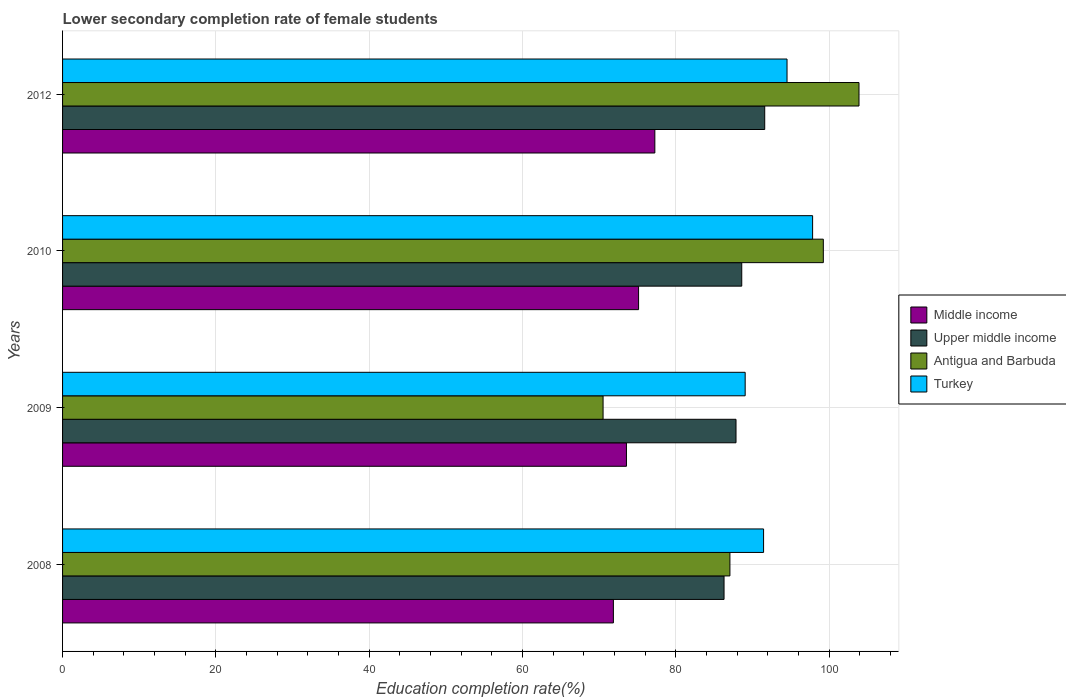How many groups of bars are there?
Provide a short and direct response. 4. Are the number of bars per tick equal to the number of legend labels?
Your answer should be compact. Yes. What is the label of the 1st group of bars from the top?
Offer a very short reply. 2012. What is the lower secondary completion rate of female students in Antigua and Barbuda in 2008?
Give a very brief answer. 87.07. Across all years, what is the maximum lower secondary completion rate of female students in Upper middle income?
Offer a terse response. 91.61. Across all years, what is the minimum lower secondary completion rate of female students in Antigua and Barbuda?
Your response must be concise. 70.52. In which year was the lower secondary completion rate of female students in Antigua and Barbuda minimum?
Give a very brief answer. 2009. What is the total lower secondary completion rate of female students in Upper middle income in the graph?
Give a very brief answer. 354.4. What is the difference between the lower secondary completion rate of female students in Middle income in 2009 and that in 2012?
Your answer should be very brief. -3.7. What is the difference between the lower secondary completion rate of female students in Middle income in 2009 and the lower secondary completion rate of female students in Antigua and Barbuda in 2008?
Provide a succinct answer. -13.5. What is the average lower secondary completion rate of female students in Turkey per year?
Offer a terse response. 93.23. In the year 2012, what is the difference between the lower secondary completion rate of female students in Turkey and lower secondary completion rate of female students in Middle income?
Ensure brevity in your answer.  17.25. What is the ratio of the lower secondary completion rate of female students in Antigua and Barbuda in 2010 to that in 2012?
Offer a very short reply. 0.96. What is the difference between the highest and the second highest lower secondary completion rate of female students in Upper middle income?
Offer a terse response. 3. What is the difference between the highest and the lowest lower secondary completion rate of female students in Upper middle income?
Provide a succinct answer. 5.31. In how many years, is the lower secondary completion rate of female students in Turkey greater than the average lower secondary completion rate of female students in Turkey taken over all years?
Ensure brevity in your answer.  2. Is the sum of the lower secondary completion rate of female students in Antigua and Barbuda in 2009 and 2010 greater than the maximum lower secondary completion rate of female students in Middle income across all years?
Make the answer very short. Yes. Is it the case that in every year, the sum of the lower secondary completion rate of female students in Upper middle income and lower secondary completion rate of female students in Middle income is greater than the sum of lower secondary completion rate of female students in Turkey and lower secondary completion rate of female students in Antigua and Barbuda?
Make the answer very short. Yes. What does the 2nd bar from the top in 2012 represents?
Offer a very short reply. Antigua and Barbuda. What does the 4th bar from the bottom in 2009 represents?
Give a very brief answer. Turkey. How many bars are there?
Your response must be concise. 16. Are all the bars in the graph horizontal?
Offer a very short reply. Yes. How many years are there in the graph?
Keep it short and to the point. 4. What is the difference between two consecutive major ticks on the X-axis?
Your answer should be very brief. 20. Does the graph contain any zero values?
Your response must be concise. No. How are the legend labels stacked?
Offer a very short reply. Vertical. What is the title of the graph?
Give a very brief answer. Lower secondary completion rate of female students. Does "United States" appear as one of the legend labels in the graph?
Offer a terse response. No. What is the label or title of the X-axis?
Your answer should be very brief. Education completion rate(%). What is the Education completion rate(%) of Middle income in 2008?
Your response must be concise. 71.87. What is the Education completion rate(%) in Upper middle income in 2008?
Your answer should be very brief. 86.31. What is the Education completion rate(%) in Antigua and Barbuda in 2008?
Provide a short and direct response. 87.07. What is the Education completion rate(%) in Turkey in 2008?
Offer a terse response. 91.46. What is the Education completion rate(%) of Middle income in 2009?
Your response must be concise. 73.57. What is the Education completion rate(%) in Upper middle income in 2009?
Ensure brevity in your answer.  87.87. What is the Education completion rate(%) of Antigua and Barbuda in 2009?
Offer a terse response. 70.52. What is the Education completion rate(%) of Turkey in 2009?
Ensure brevity in your answer.  89.06. What is the Education completion rate(%) in Middle income in 2010?
Your answer should be compact. 75.15. What is the Education completion rate(%) in Upper middle income in 2010?
Your response must be concise. 88.62. What is the Education completion rate(%) in Antigua and Barbuda in 2010?
Provide a succinct answer. 99.26. What is the Education completion rate(%) of Turkey in 2010?
Your answer should be very brief. 97.86. What is the Education completion rate(%) of Middle income in 2012?
Give a very brief answer. 77.28. What is the Education completion rate(%) in Upper middle income in 2012?
Provide a succinct answer. 91.61. What is the Education completion rate(%) in Antigua and Barbuda in 2012?
Your answer should be compact. 103.91. What is the Education completion rate(%) of Turkey in 2012?
Offer a terse response. 94.52. Across all years, what is the maximum Education completion rate(%) in Middle income?
Your answer should be compact. 77.28. Across all years, what is the maximum Education completion rate(%) in Upper middle income?
Give a very brief answer. 91.61. Across all years, what is the maximum Education completion rate(%) in Antigua and Barbuda?
Make the answer very short. 103.91. Across all years, what is the maximum Education completion rate(%) of Turkey?
Offer a very short reply. 97.86. Across all years, what is the minimum Education completion rate(%) in Middle income?
Offer a very short reply. 71.87. Across all years, what is the minimum Education completion rate(%) in Upper middle income?
Make the answer very short. 86.31. Across all years, what is the minimum Education completion rate(%) in Antigua and Barbuda?
Offer a very short reply. 70.52. Across all years, what is the minimum Education completion rate(%) of Turkey?
Your response must be concise. 89.06. What is the total Education completion rate(%) in Middle income in the graph?
Make the answer very short. 297.87. What is the total Education completion rate(%) of Upper middle income in the graph?
Ensure brevity in your answer.  354.4. What is the total Education completion rate(%) in Antigua and Barbuda in the graph?
Provide a succinct answer. 360.77. What is the total Education completion rate(%) of Turkey in the graph?
Keep it short and to the point. 372.91. What is the difference between the Education completion rate(%) of Middle income in 2008 and that in 2009?
Your answer should be very brief. -1.7. What is the difference between the Education completion rate(%) of Upper middle income in 2008 and that in 2009?
Provide a short and direct response. -1.56. What is the difference between the Education completion rate(%) of Antigua and Barbuda in 2008 and that in 2009?
Provide a short and direct response. 16.55. What is the difference between the Education completion rate(%) of Turkey in 2008 and that in 2009?
Make the answer very short. 2.4. What is the difference between the Education completion rate(%) in Middle income in 2008 and that in 2010?
Your answer should be compact. -3.29. What is the difference between the Education completion rate(%) in Upper middle income in 2008 and that in 2010?
Offer a terse response. -2.31. What is the difference between the Education completion rate(%) of Antigua and Barbuda in 2008 and that in 2010?
Provide a succinct answer. -12.19. What is the difference between the Education completion rate(%) in Turkey in 2008 and that in 2010?
Your answer should be compact. -6.4. What is the difference between the Education completion rate(%) in Middle income in 2008 and that in 2012?
Keep it short and to the point. -5.41. What is the difference between the Education completion rate(%) in Upper middle income in 2008 and that in 2012?
Your response must be concise. -5.31. What is the difference between the Education completion rate(%) of Antigua and Barbuda in 2008 and that in 2012?
Provide a succinct answer. -16.84. What is the difference between the Education completion rate(%) of Turkey in 2008 and that in 2012?
Keep it short and to the point. -3.06. What is the difference between the Education completion rate(%) in Middle income in 2009 and that in 2010?
Ensure brevity in your answer.  -1.58. What is the difference between the Education completion rate(%) in Upper middle income in 2009 and that in 2010?
Your answer should be compact. -0.75. What is the difference between the Education completion rate(%) in Antigua and Barbuda in 2009 and that in 2010?
Keep it short and to the point. -28.74. What is the difference between the Education completion rate(%) in Turkey in 2009 and that in 2010?
Offer a terse response. -8.8. What is the difference between the Education completion rate(%) in Middle income in 2009 and that in 2012?
Provide a short and direct response. -3.7. What is the difference between the Education completion rate(%) in Upper middle income in 2009 and that in 2012?
Make the answer very short. -3.75. What is the difference between the Education completion rate(%) in Antigua and Barbuda in 2009 and that in 2012?
Your answer should be very brief. -33.39. What is the difference between the Education completion rate(%) of Turkey in 2009 and that in 2012?
Your answer should be very brief. -5.46. What is the difference between the Education completion rate(%) in Middle income in 2010 and that in 2012?
Provide a succinct answer. -2.12. What is the difference between the Education completion rate(%) in Upper middle income in 2010 and that in 2012?
Keep it short and to the point. -3. What is the difference between the Education completion rate(%) of Antigua and Barbuda in 2010 and that in 2012?
Your answer should be very brief. -4.65. What is the difference between the Education completion rate(%) in Turkey in 2010 and that in 2012?
Keep it short and to the point. 3.34. What is the difference between the Education completion rate(%) of Middle income in 2008 and the Education completion rate(%) of Upper middle income in 2009?
Offer a terse response. -16. What is the difference between the Education completion rate(%) of Middle income in 2008 and the Education completion rate(%) of Antigua and Barbuda in 2009?
Provide a succinct answer. 1.35. What is the difference between the Education completion rate(%) of Middle income in 2008 and the Education completion rate(%) of Turkey in 2009?
Give a very brief answer. -17.19. What is the difference between the Education completion rate(%) of Upper middle income in 2008 and the Education completion rate(%) of Antigua and Barbuda in 2009?
Keep it short and to the point. 15.78. What is the difference between the Education completion rate(%) in Upper middle income in 2008 and the Education completion rate(%) in Turkey in 2009?
Give a very brief answer. -2.76. What is the difference between the Education completion rate(%) in Antigua and Barbuda in 2008 and the Education completion rate(%) in Turkey in 2009?
Provide a succinct answer. -1.99. What is the difference between the Education completion rate(%) in Middle income in 2008 and the Education completion rate(%) in Upper middle income in 2010?
Ensure brevity in your answer.  -16.75. What is the difference between the Education completion rate(%) in Middle income in 2008 and the Education completion rate(%) in Antigua and Barbuda in 2010?
Give a very brief answer. -27.39. What is the difference between the Education completion rate(%) of Middle income in 2008 and the Education completion rate(%) of Turkey in 2010?
Your answer should be compact. -25.99. What is the difference between the Education completion rate(%) of Upper middle income in 2008 and the Education completion rate(%) of Antigua and Barbuda in 2010?
Make the answer very short. -12.95. What is the difference between the Education completion rate(%) in Upper middle income in 2008 and the Education completion rate(%) in Turkey in 2010?
Give a very brief answer. -11.55. What is the difference between the Education completion rate(%) in Antigua and Barbuda in 2008 and the Education completion rate(%) in Turkey in 2010?
Your answer should be very brief. -10.79. What is the difference between the Education completion rate(%) of Middle income in 2008 and the Education completion rate(%) of Upper middle income in 2012?
Make the answer very short. -19.74. What is the difference between the Education completion rate(%) of Middle income in 2008 and the Education completion rate(%) of Antigua and Barbuda in 2012?
Provide a succinct answer. -32.04. What is the difference between the Education completion rate(%) of Middle income in 2008 and the Education completion rate(%) of Turkey in 2012?
Ensure brevity in your answer.  -22.65. What is the difference between the Education completion rate(%) in Upper middle income in 2008 and the Education completion rate(%) in Antigua and Barbuda in 2012?
Your answer should be compact. -17.61. What is the difference between the Education completion rate(%) of Upper middle income in 2008 and the Education completion rate(%) of Turkey in 2012?
Ensure brevity in your answer.  -8.22. What is the difference between the Education completion rate(%) in Antigua and Barbuda in 2008 and the Education completion rate(%) in Turkey in 2012?
Offer a very short reply. -7.45. What is the difference between the Education completion rate(%) in Middle income in 2009 and the Education completion rate(%) in Upper middle income in 2010?
Ensure brevity in your answer.  -15.04. What is the difference between the Education completion rate(%) of Middle income in 2009 and the Education completion rate(%) of Antigua and Barbuda in 2010?
Your answer should be very brief. -25.69. What is the difference between the Education completion rate(%) in Middle income in 2009 and the Education completion rate(%) in Turkey in 2010?
Provide a short and direct response. -24.29. What is the difference between the Education completion rate(%) in Upper middle income in 2009 and the Education completion rate(%) in Antigua and Barbuda in 2010?
Ensure brevity in your answer.  -11.39. What is the difference between the Education completion rate(%) in Upper middle income in 2009 and the Education completion rate(%) in Turkey in 2010?
Ensure brevity in your answer.  -9.99. What is the difference between the Education completion rate(%) in Antigua and Barbuda in 2009 and the Education completion rate(%) in Turkey in 2010?
Your answer should be compact. -27.34. What is the difference between the Education completion rate(%) of Middle income in 2009 and the Education completion rate(%) of Upper middle income in 2012?
Provide a short and direct response. -18.04. What is the difference between the Education completion rate(%) in Middle income in 2009 and the Education completion rate(%) in Antigua and Barbuda in 2012?
Give a very brief answer. -30.34. What is the difference between the Education completion rate(%) of Middle income in 2009 and the Education completion rate(%) of Turkey in 2012?
Keep it short and to the point. -20.95. What is the difference between the Education completion rate(%) of Upper middle income in 2009 and the Education completion rate(%) of Antigua and Barbuda in 2012?
Your response must be concise. -16.05. What is the difference between the Education completion rate(%) of Upper middle income in 2009 and the Education completion rate(%) of Turkey in 2012?
Provide a short and direct response. -6.66. What is the difference between the Education completion rate(%) of Antigua and Barbuda in 2009 and the Education completion rate(%) of Turkey in 2012?
Your answer should be compact. -24. What is the difference between the Education completion rate(%) of Middle income in 2010 and the Education completion rate(%) of Upper middle income in 2012?
Your answer should be very brief. -16.46. What is the difference between the Education completion rate(%) in Middle income in 2010 and the Education completion rate(%) in Antigua and Barbuda in 2012?
Keep it short and to the point. -28.76. What is the difference between the Education completion rate(%) in Middle income in 2010 and the Education completion rate(%) in Turkey in 2012?
Your answer should be compact. -19.37. What is the difference between the Education completion rate(%) of Upper middle income in 2010 and the Education completion rate(%) of Antigua and Barbuda in 2012?
Ensure brevity in your answer.  -15.3. What is the difference between the Education completion rate(%) in Upper middle income in 2010 and the Education completion rate(%) in Turkey in 2012?
Your response must be concise. -5.91. What is the difference between the Education completion rate(%) in Antigua and Barbuda in 2010 and the Education completion rate(%) in Turkey in 2012?
Provide a succinct answer. 4.74. What is the average Education completion rate(%) in Middle income per year?
Give a very brief answer. 74.47. What is the average Education completion rate(%) of Upper middle income per year?
Ensure brevity in your answer.  88.6. What is the average Education completion rate(%) in Antigua and Barbuda per year?
Ensure brevity in your answer.  90.19. What is the average Education completion rate(%) of Turkey per year?
Offer a very short reply. 93.23. In the year 2008, what is the difference between the Education completion rate(%) in Middle income and Education completion rate(%) in Upper middle income?
Make the answer very short. -14.44. In the year 2008, what is the difference between the Education completion rate(%) in Middle income and Education completion rate(%) in Antigua and Barbuda?
Ensure brevity in your answer.  -15.2. In the year 2008, what is the difference between the Education completion rate(%) of Middle income and Education completion rate(%) of Turkey?
Keep it short and to the point. -19.59. In the year 2008, what is the difference between the Education completion rate(%) of Upper middle income and Education completion rate(%) of Antigua and Barbuda?
Your answer should be compact. -0.77. In the year 2008, what is the difference between the Education completion rate(%) in Upper middle income and Education completion rate(%) in Turkey?
Make the answer very short. -5.16. In the year 2008, what is the difference between the Education completion rate(%) in Antigua and Barbuda and Education completion rate(%) in Turkey?
Provide a short and direct response. -4.39. In the year 2009, what is the difference between the Education completion rate(%) in Middle income and Education completion rate(%) in Upper middle income?
Your response must be concise. -14.29. In the year 2009, what is the difference between the Education completion rate(%) in Middle income and Education completion rate(%) in Antigua and Barbuda?
Ensure brevity in your answer.  3.05. In the year 2009, what is the difference between the Education completion rate(%) of Middle income and Education completion rate(%) of Turkey?
Your answer should be compact. -15.49. In the year 2009, what is the difference between the Education completion rate(%) of Upper middle income and Education completion rate(%) of Antigua and Barbuda?
Offer a very short reply. 17.34. In the year 2009, what is the difference between the Education completion rate(%) of Upper middle income and Education completion rate(%) of Turkey?
Your answer should be compact. -1.2. In the year 2009, what is the difference between the Education completion rate(%) of Antigua and Barbuda and Education completion rate(%) of Turkey?
Offer a very short reply. -18.54. In the year 2010, what is the difference between the Education completion rate(%) in Middle income and Education completion rate(%) in Upper middle income?
Your response must be concise. -13.46. In the year 2010, what is the difference between the Education completion rate(%) in Middle income and Education completion rate(%) in Antigua and Barbuda?
Give a very brief answer. -24.11. In the year 2010, what is the difference between the Education completion rate(%) of Middle income and Education completion rate(%) of Turkey?
Your response must be concise. -22.71. In the year 2010, what is the difference between the Education completion rate(%) in Upper middle income and Education completion rate(%) in Antigua and Barbuda?
Offer a very short reply. -10.64. In the year 2010, what is the difference between the Education completion rate(%) in Upper middle income and Education completion rate(%) in Turkey?
Keep it short and to the point. -9.24. In the year 2010, what is the difference between the Education completion rate(%) in Antigua and Barbuda and Education completion rate(%) in Turkey?
Provide a succinct answer. 1.4. In the year 2012, what is the difference between the Education completion rate(%) of Middle income and Education completion rate(%) of Upper middle income?
Ensure brevity in your answer.  -14.34. In the year 2012, what is the difference between the Education completion rate(%) in Middle income and Education completion rate(%) in Antigua and Barbuda?
Keep it short and to the point. -26.64. In the year 2012, what is the difference between the Education completion rate(%) of Middle income and Education completion rate(%) of Turkey?
Your answer should be very brief. -17.25. In the year 2012, what is the difference between the Education completion rate(%) in Upper middle income and Education completion rate(%) in Antigua and Barbuda?
Ensure brevity in your answer.  -12.3. In the year 2012, what is the difference between the Education completion rate(%) in Upper middle income and Education completion rate(%) in Turkey?
Your answer should be compact. -2.91. In the year 2012, what is the difference between the Education completion rate(%) of Antigua and Barbuda and Education completion rate(%) of Turkey?
Your answer should be compact. 9.39. What is the ratio of the Education completion rate(%) of Middle income in 2008 to that in 2009?
Keep it short and to the point. 0.98. What is the ratio of the Education completion rate(%) of Upper middle income in 2008 to that in 2009?
Give a very brief answer. 0.98. What is the ratio of the Education completion rate(%) in Antigua and Barbuda in 2008 to that in 2009?
Your answer should be compact. 1.23. What is the ratio of the Education completion rate(%) of Turkey in 2008 to that in 2009?
Offer a very short reply. 1.03. What is the ratio of the Education completion rate(%) of Middle income in 2008 to that in 2010?
Give a very brief answer. 0.96. What is the ratio of the Education completion rate(%) of Upper middle income in 2008 to that in 2010?
Provide a short and direct response. 0.97. What is the ratio of the Education completion rate(%) in Antigua and Barbuda in 2008 to that in 2010?
Ensure brevity in your answer.  0.88. What is the ratio of the Education completion rate(%) of Turkey in 2008 to that in 2010?
Your response must be concise. 0.93. What is the ratio of the Education completion rate(%) in Upper middle income in 2008 to that in 2012?
Give a very brief answer. 0.94. What is the ratio of the Education completion rate(%) in Antigua and Barbuda in 2008 to that in 2012?
Offer a very short reply. 0.84. What is the ratio of the Education completion rate(%) in Turkey in 2008 to that in 2012?
Offer a very short reply. 0.97. What is the ratio of the Education completion rate(%) of Antigua and Barbuda in 2009 to that in 2010?
Ensure brevity in your answer.  0.71. What is the ratio of the Education completion rate(%) of Turkey in 2009 to that in 2010?
Offer a terse response. 0.91. What is the ratio of the Education completion rate(%) in Middle income in 2009 to that in 2012?
Offer a terse response. 0.95. What is the ratio of the Education completion rate(%) in Upper middle income in 2009 to that in 2012?
Make the answer very short. 0.96. What is the ratio of the Education completion rate(%) in Antigua and Barbuda in 2009 to that in 2012?
Give a very brief answer. 0.68. What is the ratio of the Education completion rate(%) of Turkey in 2009 to that in 2012?
Keep it short and to the point. 0.94. What is the ratio of the Education completion rate(%) of Middle income in 2010 to that in 2012?
Your response must be concise. 0.97. What is the ratio of the Education completion rate(%) in Upper middle income in 2010 to that in 2012?
Your answer should be compact. 0.97. What is the ratio of the Education completion rate(%) of Antigua and Barbuda in 2010 to that in 2012?
Offer a very short reply. 0.96. What is the ratio of the Education completion rate(%) of Turkey in 2010 to that in 2012?
Your answer should be compact. 1.04. What is the difference between the highest and the second highest Education completion rate(%) of Middle income?
Keep it short and to the point. 2.12. What is the difference between the highest and the second highest Education completion rate(%) of Upper middle income?
Provide a short and direct response. 3. What is the difference between the highest and the second highest Education completion rate(%) of Antigua and Barbuda?
Make the answer very short. 4.65. What is the difference between the highest and the second highest Education completion rate(%) of Turkey?
Your response must be concise. 3.34. What is the difference between the highest and the lowest Education completion rate(%) in Middle income?
Offer a terse response. 5.41. What is the difference between the highest and the lowest Education completion rate(%) of Upper middle income?
Provide a succinct answer. 5.31. What is the difference between the highest and the lowest Education completion rate(%) in Antigua and Barbuda?
Make the answer very short. 33.39. What is the difference between the highest and the lowest Education completion rate(%) in Turkey?
Offer a terse response. 8.8. 